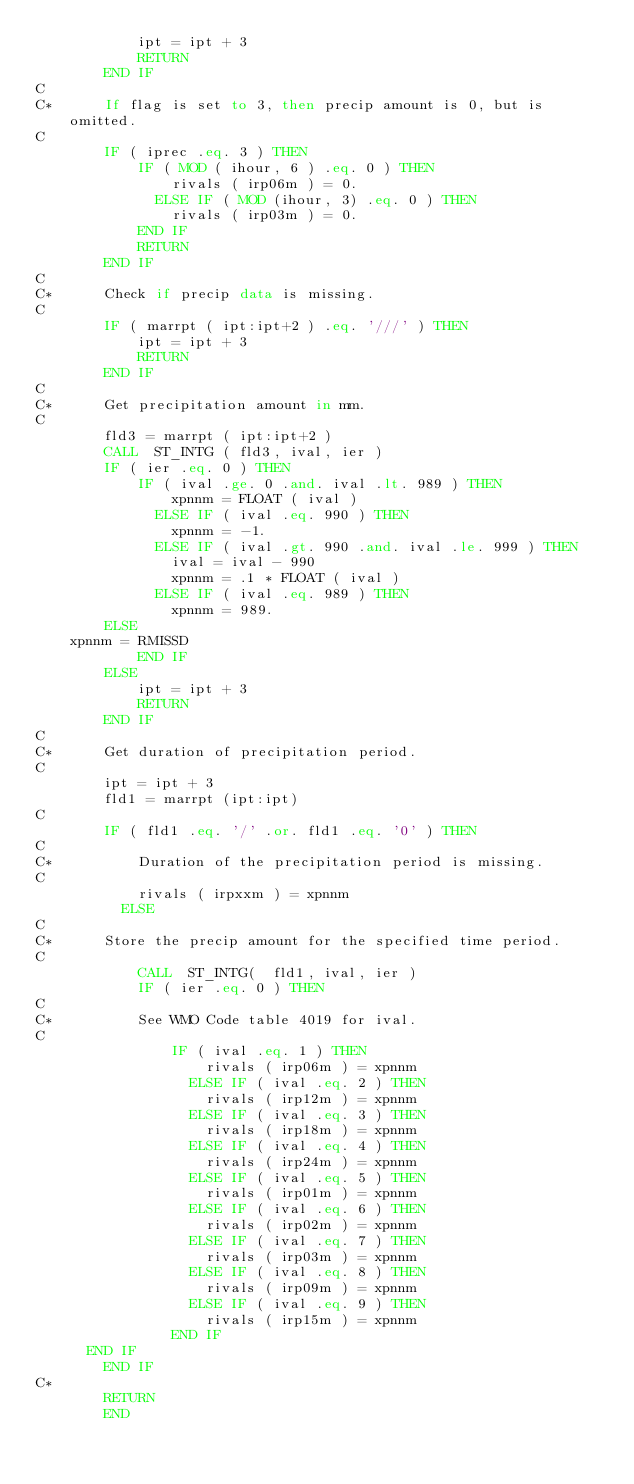Convert code to text. <code><loc_0><loc_0><loc_500><loc_500><_FORTRAN_>            ipt = ipt + 3
            RETURN
        END IF
C
C*      If flag is set to 3, then precip amount is 0, but is omitted.
C
        IF ( iprec .eq. 3 ) THEN
            IF ( MOD ( ihour, 6 ) .eq. 0 ) THEN
                rivals ( irp06m ) = 0.
              ELSE IF ( MOD (ihour, 3) .eq. 0 ) THEN
                rivals ( irp03m ) = 0.
            END IF
            RETURN
        END IF
C
C*      Check if precip data is missing.
C
        IF ( marrpt ( ipt:ipt+2 ) .eq. '///' ) THEN
            ipt = ipt + 3
            RETURN
        END IF
C
C*      Get precipitation amount in mm.
C
        fld3 = marrpt ( ipt:ipt+2 )
        CALL  ST_INTG ( fld3, ival, ier )
        IF ( ier .eq. 0 ) THEN
            IF ( ival .ge. 0 .and. ival .lt. 989 ) THEN
                xpnnm = FLOAT ( ival )    
              ELSE IF ( ival .eq. 990 ) THEN
                xpnnm = -1.
              ELSE IF ( ival .gt. 990 .and. ival .le. 999 ) THEN
                ival = ival - 990
                xpnnm = .1 * FLOAT ( ival )
              ELSE IF ( ival .eq. 989 ) THEN
                xpnnm = 989.
	      ELSE
		xpnnm = RMISSD
            END IF
        ELSE
            ipt = ipt + 3
            RETURN
        END IF
C
C*      Get duration of precipitation period.
C
        ipt = ipt + 3
        fld1 = marrpt (ipt:ipt)
C
        IF ( fld1 .eq. '/' .or. fld1 .eq. '0' ) THEN
C
C*          Duration of the precipitation period is missing.
C
            rivals ( irpxxm ) = xpnnm
          ELSE
C
C*	    Store the precip amount for the specified time period.
C
            CALL  ST_INTG(  fld1, ival, ier )
            IF ( ier .eq. 0 ) THEN
C
C* 	        See WMO Code table 4019 for ival.
C
                IF ( ival .eq. 1 ) THEN
                    rivals ( irp06m ) = xpnnm
                  ELSE IF ( ival .eq. 2 ) THEN
                    rivals ( irp12m ) = xpnnm
                  ELSE IF ( ival .eq. 3 ) THEN
                    rivals ( irp18m ) = xpnnm
                  ELSE IF ( ival .eq. 4 ) THEN
                    rivals ( irp24m ) = xpnnm
                  ELSE IF ( ival .eq. 5 ) THEN
                    rivals ( irp01m ) = xpnnm
                  ELSE IF ( ival .eq. 6 ) THEN
                    rivals ( irp02m ) = xpnnm
                  ELSE IF ( ival .eq. 7 ) THEN
                    rivals ( irp03m ) = xpnnm
                  ELSE IF ( ival .eq. 8 ) THEN
                    rivals ( irp09m ) = xpnnm
                  ELSE IF ( ival .eq. 9 ) THEN
                    rivals ( irp15m ) = xpnnm
                END IF
	    END IF
        END IF
C*
        RETURN
        END
</code> 